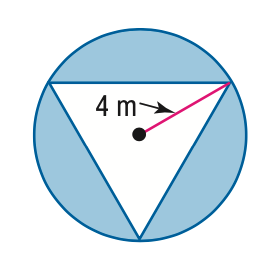Question: Find the area of the shaded region. Assume that the triangle is equilateral.
Choices:
A. 20.8
B. 29.5
C. 50.3
D. 71.1
Answer with the letter. Answer: B 